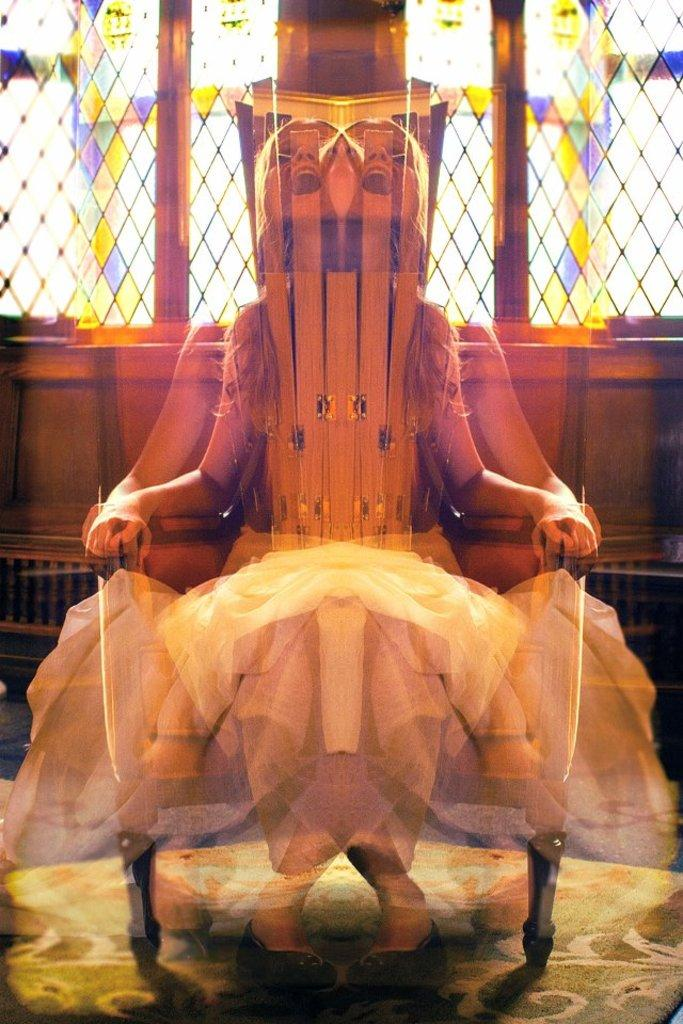What is the person in the image doing? The person is sitting on a chair. Where is the chair located? The chair is placed on the floor. What can be seen in the background of the image? There is a window in the background of the image. On which part of the room is the window located? The window is on a wall. What type of hammer is the person holding in the image? There is no hammer present in the image; the person is simply sitting on a chair. 